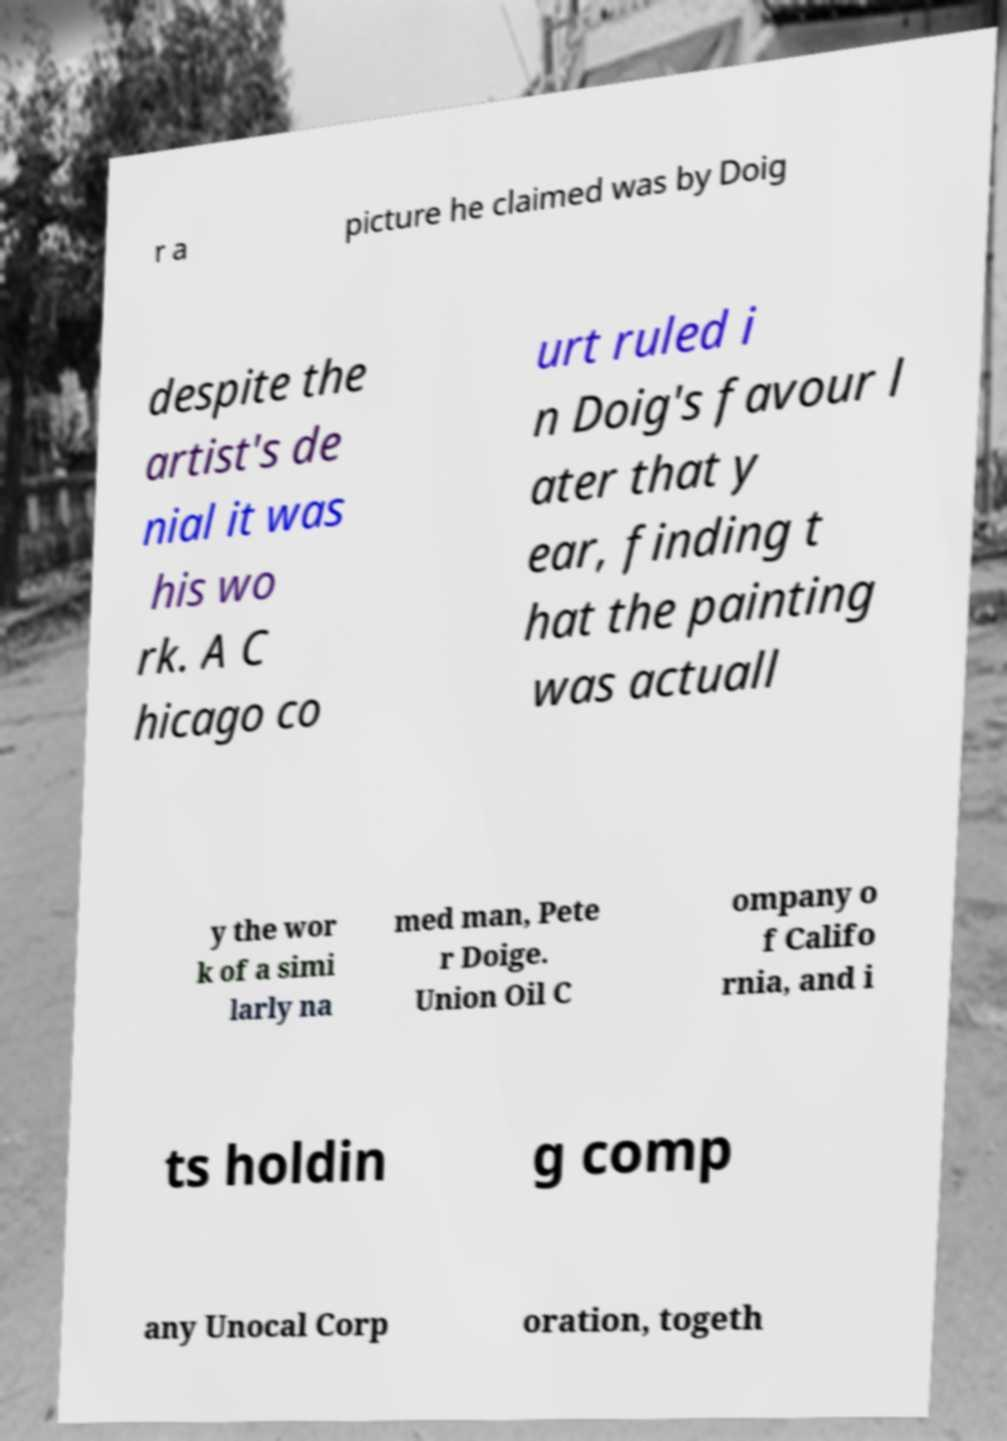I need the written content from this picture converted into text. Can you do that? r a picture he claimed was by Doig despite the artist's de nial it was his wo rk. A C hicago co urt ruled i n Doig's favour l ater that y ear, finding t hat the painting was actuall y the wor k of a simi larly na med man, Pete r Doige. Union Oil C ompany o f Califo rnia, and i ts holdin g comp any Unocal Corp oration, togeth 